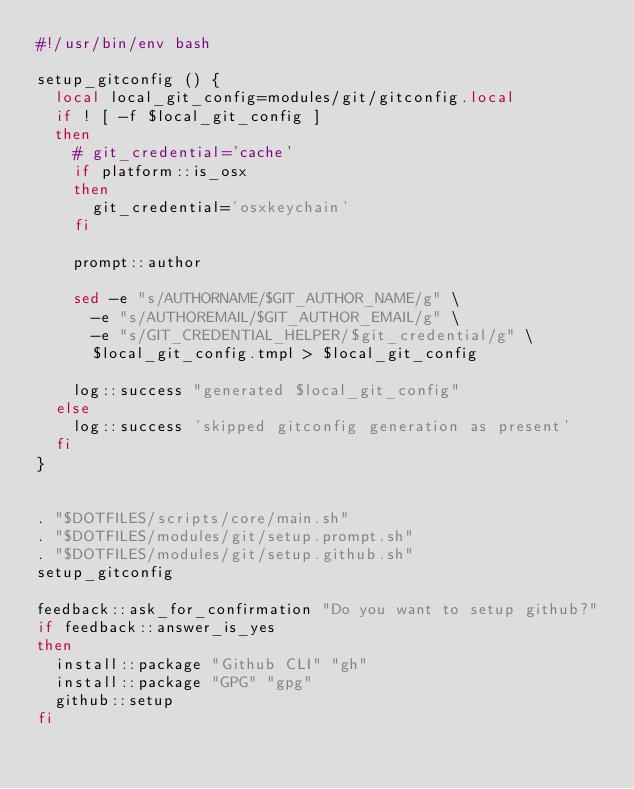<code> <loc_0><loc_0><loc_500><loc_500><_Bash_>#!/usr/bin/env bash

setup_gitconfig () {
  local local_git_config=modules/git/gitconfig.local
  if ! [ -f $local_git_config ]
  then
    # git_credential='cache'
    if platform::is_osx
    then
      git_credential='osxkeychain'
    fi

    prompt::author

    sed -e "s/AUTHORNAME/$GIT_AUTHOR_NAME/g" \
      -e "s/AUTHOREMAIL/$GIT_AUTHOR_EMAIL/g" \
      -e "s/GIT_CREDENTIAL_HELPER/$git_credential/g" \
      $local_git_config.tmpl > $local_git_config

    log::success "generated $local_git_config"
  else
    log::success 'skipped gitconfig generation as present'
  fi
}


. "$DOTFILES/scripts/core/main.sh"
. "$DOTFILES/modules/git/setup.prompt.sh"
. "$DOTFILES/modules/git/setup.github.sh"
setup_gitconfig

feedback::ask_for_confirmation "Do you want to setup github?"
if feedback::answer_is_yes
then
  install::package "Github CLI" "gh"
  install::package "GPG" "gpg"
  github::setup
fi</code> 